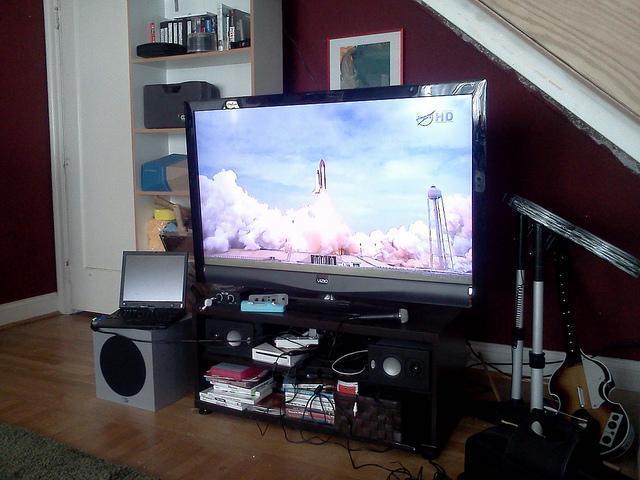How many books are visible?
Give a very brief answer. 2. 